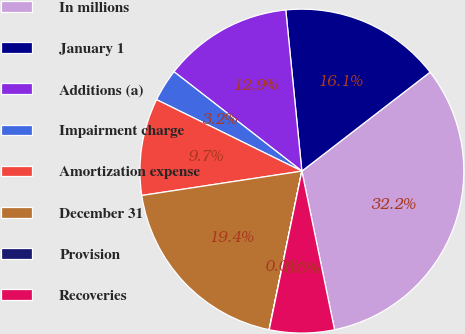<chart> <loc_0><loc_0><loc_500><loc_500><pie_chart><fcel>In millions<fcel>January 1<fcel>Additions (a)<fcel>Impairment charge<fcel>Amortization expense<fcel>December 31<fcel>Provision<fcel>Recoveries<nl><fcel>32.23%<fcel>16.12%<fcel>12.9%<fcel>3.24%<fcel>9.68%<fcel>19.35%<fcel>0.02%<fcel>6.46%<nl></chart> 